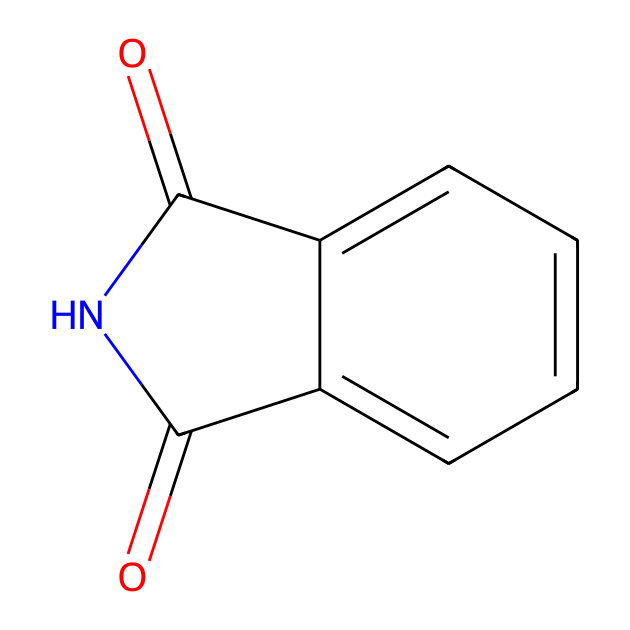How many nitrogen atoms are in phthalimide? The structure includes one nitrogen atom, which can be identified from the 'N' in the chemical formula.
Answer: one What type of functional groups are present in phthalimide? Phthalimide contains carbonyl (C=O) and imide (-C(=O)N-) functional groups, identifiable from the double bonds and nitrogen connection.
Answer: carbonyl and imide What is the molecular formula of phthalimide? The molecular formula can be derived by counting the atoms represented in the SMILES; it has 8 carbons, 5 hydrogens, 1 nitrogen, and 2 oxygens, leading to the formula C8H5N1O2.
Answer: C8H5NO2 What is the primary structural feature of phthalimide that classifies it as an imide? The imide classification arises from the presence of two carbonyl groups bonded to the same nitrogen atom, which is characteristic of imide structures.
Answer: nitrogen bonded to two carbonyls How many total rings are present in the phthalimide structure? The structure has one aromatic ring (the benzene portion) fused with a five-membered ring containing the nitrogen and carbonyls, thus counting as one ring.
Answer: one Why is phthalimide considered a building block in organic synthesis? Phthalimide has reactive sites (particularly the nitrogen in the imide group) that can participate in various chemical reactions, making it a useful intermediate in chemical syntheses.
Answer: reactive sites for synthesis 